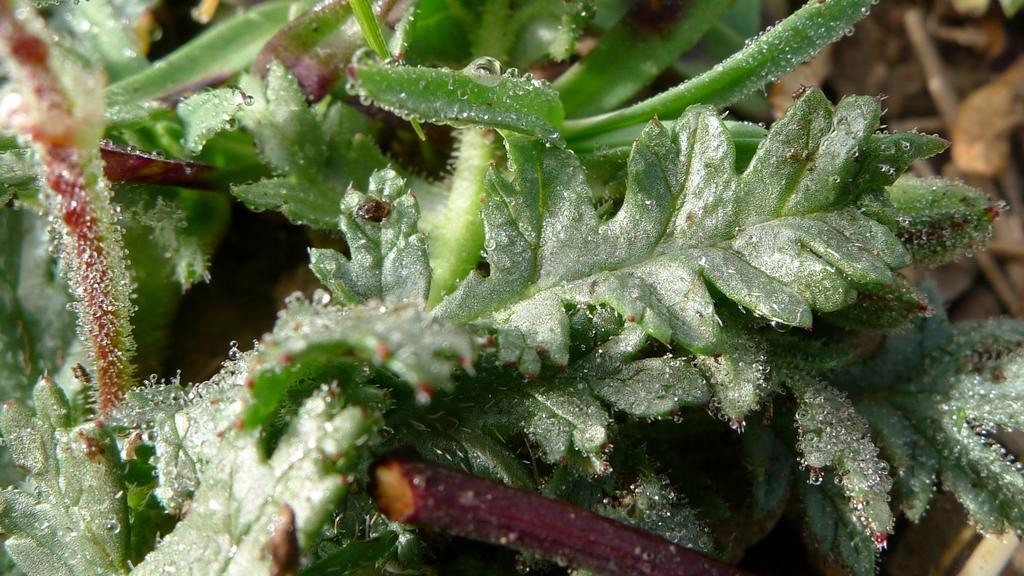What type of living organisms can be seen in the image? Plants can be seen in the image. Can you describe the condition of the plants in the image? There are water droplets on the leaves of the plants. What else can be seen at the right side of the image? There are dry leaves visible at the right side of the image. What type of meat is being served at the meeting in the image? There is no meeting or meat present in the image; it features plants with water droplets on their leaves and dry leaves. Can you tell me how many grandmothers are visible in the image? There are no grandmothers present in the image; it features plants with water droplets on their leaves and dry leaves. 